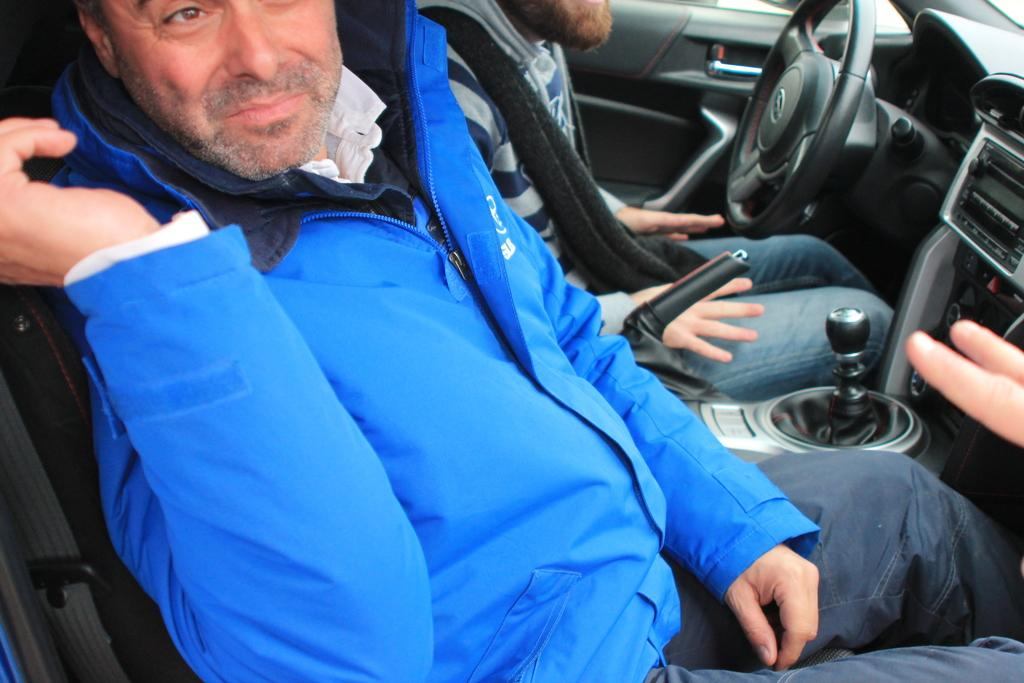How many people are in the image? There are two men in the image. What are the two men doing in the image? The two men are sitting inside a car. What type of bottle can be seen in the throat of one of the men in the image? There is no bottle or any object in anyone's throat in the image. 